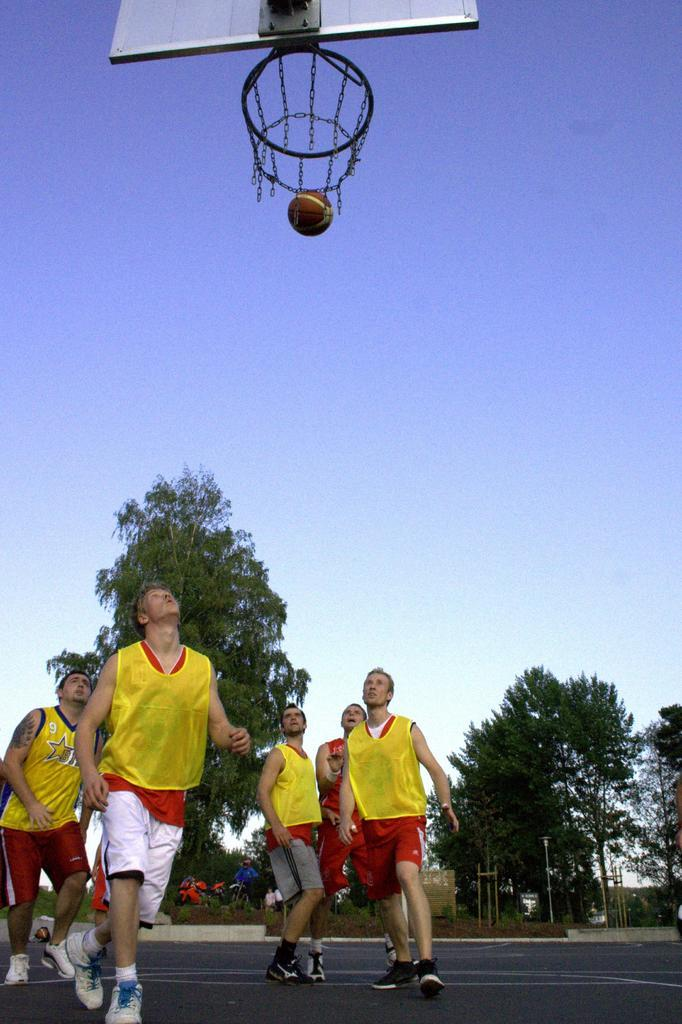Who or what can be seen in the image? There are people in the image. What can be seen in the distance behind the people? There are trees and the sky visible in the background of the image. What activity might the people be engaged in? The presence of a basketball net and a basketball in the image suggests that they might be playing basketball. What type of apparel is the truck wearing in the image? There is no truck present in the image, and therefore no apparel can be associated with it. 